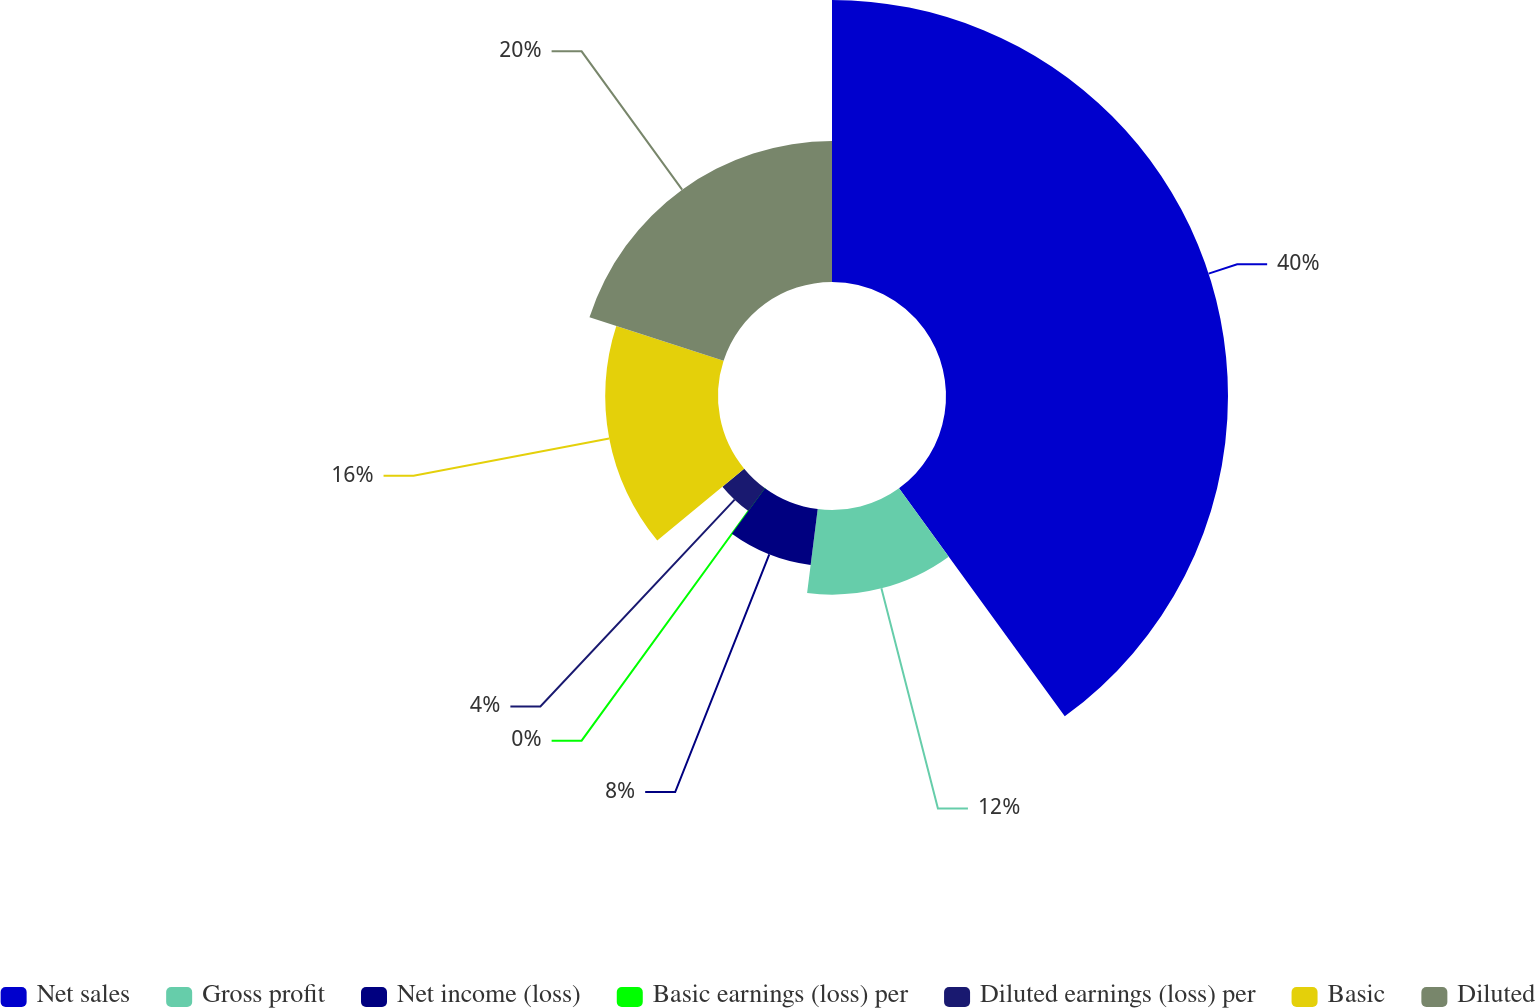Convert chart to OTSL. <chart><loc_0><loc_0><loc_500><loc_500><pie_chart><fcel>Net sales<fcel>Gross profit<fcel>Net income (loss)<fcel>Basic earnings (loss) per<fcel>Diluted earnings (loss) per<fcel>Basic<fcel>Diluted<nl><fcel>40.0%<fcel>12.0%<fcel>8.0%<fcel>0.0%<fcel>4.0%<fcel>16.0%<fcel>20.0%<nl></chart> 